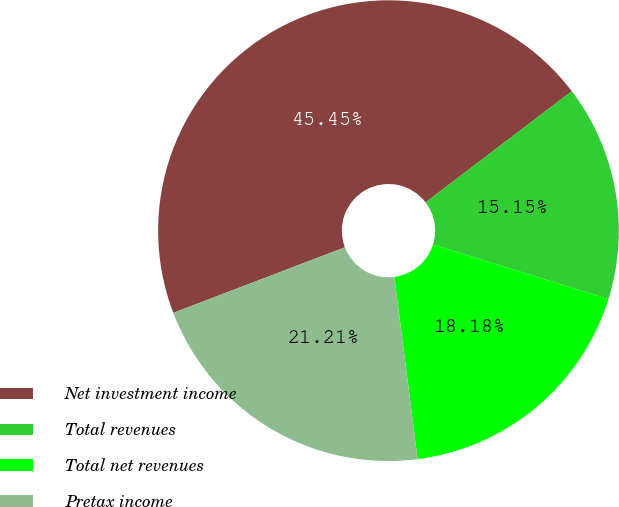<chart> <loc_0><loc_0><loc_500><loc_500><pie_chart><fcel>Net investment income<fcel>Total revenues<fcel>Total net revenues<fcel>Pretax income<nl><fcel>45.45%<fcel>15.15%<fcel>18.18%<fcel>21.21%<nl></chart> 